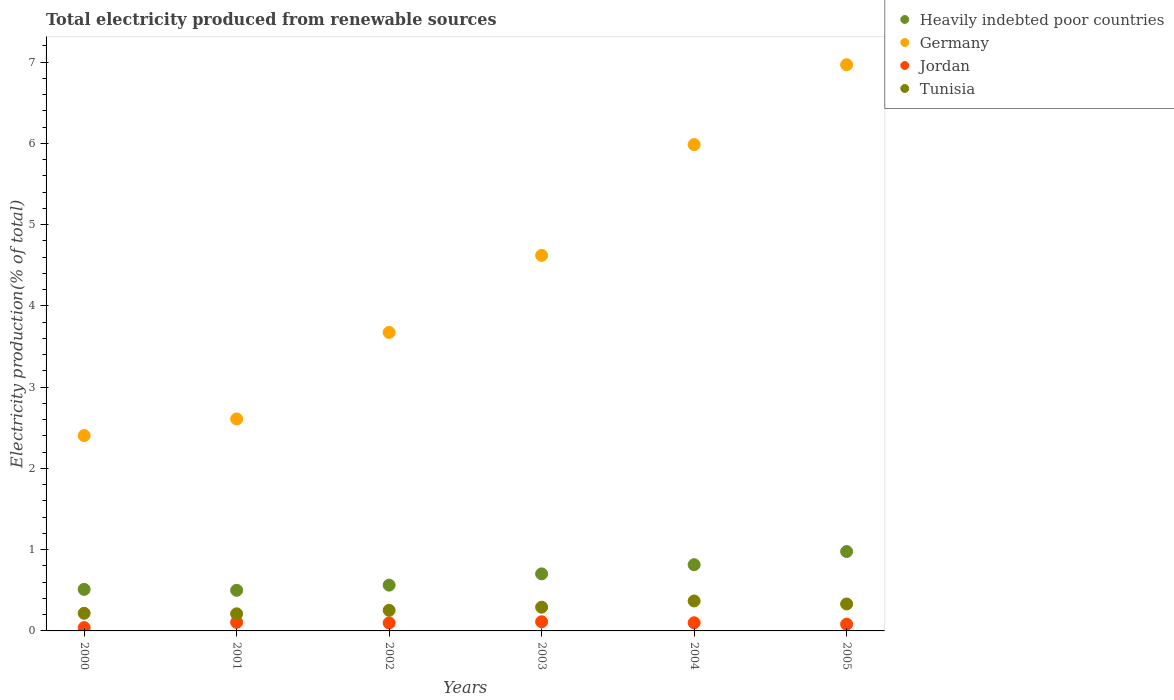How many different coloured dotlines are there?
Your answer should be compact. 4. What is the total electricity produced in Tunisia in 2001?
Offer a very short reply. 0.21. Across all years, what is the maximum total electricity produced in Jordan?
Offer a very short reply. 0.11. Across all years, what is the minimum total electricity produced in Germany?
Your response must be concise. 2.4. In which year was the total electricity produced in Jordan maximum?
Your answer should be very brief. 2003. In which year was the total electricity produced in Heavily indebted poor countries minimum?
Keep it short and to the point. 2001. What is the total total electricity produced in Jordan in the graph?
Provide a succinct answer. 0.54. What is the difference between the total electricity produced in Jordan in 2001 and that in 2002?
Keep it short and to the point. 0.01. What is the difference between the total electricity produced in Jordan in 2003 and the total electricity produced in Heavily indebted poor countries in 2000?
Your response must be concise. -0.4. What is the average total electricity produced in Germany per year?
Keep it short and to the point. 4.38. In the year 2000, what is the difference between the total electricity produced in Jordan and total electricity produced in Heavily indebted poor countries?
Your answer should be compact. -0.47. What is the ratio of the total electricity produced in Jordan in 2000 to that in 2004?
Make the answer very short. 0.41. Is the total electricity produced in Germany in 2002 less than that in 2005?
Ensure brevity in your answer.  Yes. What is the difference between the highest and the second highest total electricity produced in Jordan?
Keep it short and to the point. 0.01. What is the difference between the highest and the lowest total electricity produced in Germany?
Provide a succinct answer. 4.56. In how many years, is the total electricity produced in Jordan greater than the average total electricity produced in Jordan taken over all years?
Provide a succinct answer. 4. Is the sum of the total electricity produced in Tunisia in 2001 and 2002 greater than the maximum total electricity produced in Jordan across all years?
Offer a very short reply. Yes. Does the total electricity produced in Tunisia monotonically increase over the years?
Ensure brevity in your answer.  No. Is the total electricity produced in Heavily indebted poor countries strictly less than the total electricity produced in Germany over the years?
Make the answer very short. Yes. How many years are there in the graph?
Give a very brief answer. 6. What is the difference between two consecutive major ticks on the Y-axis?
Your answer should be compact. 1. Are the values on the major ticks of Y-axis written in scientific E-notation?
Ensure brevity in your answer.  No. Does the graph contain any zero values?
Your response must be concise. No. Does the graph contain grids?
Your response must be concise. No. Where does the legend appear in the graph?
Give a very brief answer. Top right. How many legend labels are there?
Make the answer very short. 4. How are the legend labels stacked?
Provide a succinct answer. Vertical. What is the title of the graph?
Your answer should be very brief. Total electricity produced from renewable sources. Does "Least developed countries" appear as one of the legend labels in the graph?
Ensure brevity in your answer.  No. What is the label or title of the Y-axis?
Keep it short and to the point. Electricity production(% of total). What is the Electricity production(% of total) in Heavily indebted poor countries in 2000?
Give a very brief answer. 0.51. What is the Electricity production(% of total) in Germany in 2000?
Offer a terse response. 2.4. What is the Electricity production(% of total) in Jordan in 2000?
Ensure brevity in your answer.  0.04. What is the Electricity production(% of total) in Tunisia in 2000?
Your answer should be very brief. 0.22. What is the Electricity production(% of total) in Heavily indebted poor countries in 2001?
Make the answer very short. 0.5. What is the Electricity production(% of total) in Germany in 2001?
Give a very brief answer. 2.61. What is the Electricity production(% of total) of Jordan in 2001?
Give a very brief answer. 0.11. What is the Electricity production(% of total) of Tunisia in 2001?
Ensure brevity in your answer.  0.21. What is the Electricity production(% of total) in Heavily indebted poor countries in 2002?
Your answer should be very brief. 0.56. What is the Electricity production(% of total) of Germany in 2002?
Make the answer very short. 3.67. What is the Electricity production(% of total) of Jordan in 2002?
Make the answer very short. 0.1. What is the Electricity production(% of total) of Tunisia in 2002?
Keep it short and to the point. 0.25. What is the Electricity production(% of total) in Heavily indebted poor countries in 2003?
Keep it short and to the point. 0.7. What is the Electricity production(% of total) in Germany in 2003?
Your answer should be compact. 4.62. What is the Electricity production(% of total) of Jordan in 2003?
Keep it short and to the point. 0.11. What is the Electricity production(% of total) in Tunisia in 2003?
Your answer should be compact. 0.29. What is the Electricity production(% of total) in Heavily indebted poor countries in 2004?
Ensure brevity in your answer.  0.82. What is the Electricity production(% of total) in Germany in 2004?
Provide a succinct answer. 5.99. What is the Electricity production(% of total) in Jordan in 2004?
Provide a succinct answer. 0.1. What is the Electricity production(% of total) in Tunisia in 2004?
Your answer should be compact. 0.37. What is the Electricity production(% of total) of Heavily indebted poor countries in 2005?
Ensure brevity in your answer.  0.98. What is the Electricity production(% of total) in Germany in 2005?
Your answer should be very brief. 6.97. What is the Electricity production(% of total) in Jordan in 2005?
Your answer should be compact. 0.08. What is the Electricity production(% of total) in Tunisia in 2005?
Offer a very short reply. 0.33. Across all years, what is the maximum Electricity production(% of total) of Heavily indebted poor countries?
Your answer should be compact. 0.98. Across all years, what is the maximum Electricity production(% of total) of Germany?
Offer a very short reply. 6.97. Across all years, what is the maximum Electricity production(% of total) in Jordan?
Your answer should be compact. 0.11. Across all years, what is the maximum Electricity production(% of total) of Tunisia?
Make the answer very short. 0.37. Across all years, what is the minimum Electricity production(% of total) in Heavily indebted poor countries?
Keep it short and to the point. 0.5. Across all years, what is the minimum Electricity production(% of total) of Germany?
Your answer should be very brief. 2.4. Across all years, what is the minimum Electricity production(% of total) of Jordan?
Ensure brevity in your answer.  0.04. Across all years, what is the minimum Electricity production(% of total) of Tunisia?
Provide a short and direct response. 0.21. What is the total Electricity production(% of total) of Heavily indebted poor countries in the graph?
Provide a short and direct response. 4.07. What is the total Electricity production(% of total) of Germany in the graph?
Keep it short and to the point. 26.26. What is the total Electricity production(% of total) of Jordan in the graph?
Your response must be concise. 0.54. What is the total Electricity production(% of total) in Tunisia in the graph?
Your response must be concise. 1.67. What is the difference between the Electricity production(% of total) of Heavily indebted poor countries in 2000 and that in 2001?
Give a very brief answer. 0.01. What is the difference between the Electricity production(% of total) in Germany in 2000 and that in 2001?
Ensure brevity in your answer.  -0.2. What is the difference between the Electricity production(% of total) in Jordan in 2000 and that in 2001?
Offer a terse response. -0.07. What is the difference between the Electricity production(% of total) of Tunisia in 2000 and that in 2001?
Provide a succinct answer. 0.01. What is the difference between the Electricity production(% of total) in Heavily indebted poor countries in 2000 and that in 2002?
Your answer should be compact. -0.05. What is the difference between the Electricity production(% of total) of Germany in 2000 and that in 2002?
Provide a short and direct response. -1.27. What is the difference between the Electricity production(% of total) of Jordan in 2000 and that in 2002?
Provide a short and direct response. -0.06. What is the difference between the Electricity production(% of total) of Tunisia in 2000 and that in 2002?
Give a very brief answer. -0.04. What is the difference between the Electricity production(% of total) of Heavily indebted poor countries in 2000 and that in 2003?
Offer a terse response. -0.19. What is the difference between the Electricity production(% of total) in Germany in 2000 and that in 2003?
Offer a terse response. -2.22. What is the difference between the Electricity production(% of total) in Jordan in 2000 and that in 2003?
Keep it short and to the point. -0.07. What is the difference between the Electricity production(% of total) in Tunisia in 2000 and that in 2003?
Provide a succinct answer. -0.08. What is the difference between the Electricity production(% of total) of Heavily indebted poor countries in 2000 and that in 2004?
Provide a short and direct response. -0.3. What is the difference between the Electricity production(% of total) in Germany in 2000 and that in 2004?
Provide a short and direct response. -3.58. What is the difference between the Electricity production(% of total) of Jordan in 2000 and that in 2004?
Your answer should be very brief. -0.06. What is the difference between the Electricity production(% of total) of Tunisia in 2000 and that in 2004?
Your answer should be very brief. -0.15. What is the difference between the Electricity production(% of total) in Heavily indebted poor countries in 2000 and that in 2005?
Offer a terse response. -0.47. What is the difference between the Electricity production(% of total) of Germany in 2000 and that in 2005?
Offer a terse response. -4.56. What is the difference between the Electricity production(% of total) in Jordan in 2000 and that in 2005?
Your response must be concise. -0.04. What is the difference between the Electricity production(% of total) in Tunisia in 2000 and that in 2005?
Give a very brief answer. -0.11. What is the difference between the Electricity production(% of total) of Heavily indebted poor countries in 2001 and that in 2002?
Provide a short and direct response. -0.06. What is the difference between the Electricity production(% of total) of Germany in 2001 and that in 2002?
Give a very brief answer. -1.06. What is the difference between the Electricity production(% of total) in Jordan in 2001 and that in 2002?
Your answer should be compact. 0.01. What is the difference between the Electricity production(% of total) in Tunisia in 2001 and that in 2002?
Make the answer very short. -0.04. What is the difference between the Electricity production(% of total) in Heavily indebted poor countries in 2001 and that in 2003?
Make the answer very short. -0.2. What is the difference between the Electricity production(% of total) of Germany in 2001 and that in 2003?
Offer a terse response. -2.01. What is the difference between the Electricity production(% of total) in Jordan in 2001 and that in 2003?
Make the answer very short. -0.01. What is the difference between the Electricity production(% of total) in Tunisia in 2001 and that in 2003?
Ensure brevity in your answer.  -0.08. What is the difference between the Electricity production(% of total) in Heavily indebted poor countries in 2001 and that in 2004?
Make the answer very short. -0.32. What is the difference between the Electricity production(% of total) of Germany in 2001 and that in 2004?
Ensure brevity in your answer.  -3.38. What is the difference between the Electricity production(% of total) in Jordan in 2001 and that in 2004?
Provide a short and direct response. 0.01. What is the difference between the Electricity production(% of total) in Tunisia in 2001 and that in 2004?
Your answer should be very brief. -0.16. What is the difference between the Electricity production(% of total) of Heavily indebted poor countries in 2001 and that in 2005?
Keep it short and to the point. -0.48. What is the difference between the Electricity production(% of total) of Germany in 2001 and that in 2005?
Provide a short and direct response. -4.36. What is the difference between the Electricity production(% of total) in Jordan in 2001 and that in 2005?
Make the answer very short. 0.02. What is the difference between the Electricity production(% of total) in Tunisia in 2001 and that in 2005?
Provide a succinct answer. -0.12. What is the difference between the Electricity production(% of total) of Heavily indebted poor countries in 2002 and that in 2003?
Provide a short and direct response. -0.14. What is the difference between the Electricity production(% of total) in Germany in 2002 and that in 2003?
Provide a short and direct response. -0.95. What is the difference between the Electricity production(% of total) in Jordan in 2002 and that in 2003?
Make the answer very short. -0.01. What is the difference between the Electricity production(% of total) in Tunisia in 2002 and that in 2003?
Offer a very short reply. -0.04. What is the difference between the Electricity production(% of total) in Heavily indebted poor countries in 2002 and that in 2004?
Your response must be concise. -0.25. What is the difference between the Electricity production(% of total) of Germany in 2002 and that in 2004?
Offer a very short reply. -2.31. What is the difference between the Electricity production(% of total) of Jordan in 2002 and that in 2004?
Make the answer very short. -0. What is the difference between the Electricity production(% of total) of Tunisia in 2002 and that in 2004?
Offer a very short reply. -0.12. What is the difference between the Electricity production(% of total) of Heavily indebted poor countries in 2002 and that in 2005?
Keep it short and to the point. -0.41. What is the difference between the Electricity production(% of total) in Germany in 2002 and that in 2005?
Ensure brevity in your answer.  -3.29. What is the difference between the Electricity production(% of total) in Jordan in 2002 and that in 2005?
Your response must be concise. 0.02. What is the difference between the Electricity production(% of total) in Tunisia in 2002 and that in 2005?
Offer a very short reply. -0.08. What is the difference between the Electricity production(% of total) in Heavily indebted poor countries in 2003 and that in 2004?
Offer a terse response. -0.11. What is the difference between the Electricity production(% of total) in Germany in 2003 and that in 2004?
Offer a terse response. -1.36. What is the difference between the Electricity production(% of total) of Jordan in 2003 and that in 2004?
Keep it short and to the point. 0.01. What is the difference between the Electricity production(% of total) of Tunisia in 2003 and that in 2004?
Offer a very short reply. -0.08. What is the difference between the Electricity production(% of total) in Heavily indebted poor countries in 2003 and that in 2005?
Provide a short and direct response. -0.28. What is the difference between the Electricity production(% of total) of Germany in 2003 and that in 2005?
Your response must be concise. -2.35. What is the difference between the Electricity production(% of total) in Jordan in 2003 and that in 2005?
Ensure brevity in your answer.  0.03. What is the difference between the Electricity production(% of total) in Tunisia in 2003 and that in 2005?
Offer a very short reply. -0.04. What is the difference between the Electricity production(% of total) in Heavily indebted poor countries in 2004 and that in 2005?
Keep it short and to the point. -0.16. What is the difference between the Electricity production(% of total) of Germany in 2004 and that in 2005?
Provide a succinct answer. -0.98. What is the difference between the Electricity production(% of total) of Jordan in 2004 and that in 2005?
Provide a short and direct response. 0.02. What is the difference between the Electricity production(% of total) of Tunisia in 2004 and that in 2005?
Keep it short and to the point. 0.04. What is the difference between the Electricity production(% of total) of Heavily indebted poor countries in 2000 and the Electricity production(% of total) of Germany in 2001?
Offer a terse response. -2.1. What is the difference between the Electricity production(% of total) in Heavily indebted poor countries in 2000 and the Electricity production(% of total) in Jordan in 2001?
Provide a succinct answer. 0.41. What is the difference between the Electricity production(% of total) of Heavily indebted poor countries in 2000 and the Electricity production(% of total) of Tunisia in 2001?
Keep it short and to the point. 0.3. What is the difference between the Electricity production(% of total) of Germany in 2000 and the Electricity production(% of total) of Jordan in 2001?
Your answer should be very brief. 2.3. What is the difference between the Electricity production(% of total) in Germany in 2000 and the Electricity production(% of total) in Tunisia in 2001?
Ensure brevity in your answer.  2.19. What is the difference between the Electricity production(% of total) in Jordan in 2000 and the Electricity production(% of total) in Tunisia in 2001?
Provide a short and direct response. -0.17. What is the difference between the Electricity production(% of total) in Heavily indebted poor countries in 2000 and the Electricity production(% of total) in Germany in 2002?
Offer a very short reply. -3.16. What is the difference between the Electricity production(% of total) in Heavily indebted poor countries in 2000 and the Electricity production(% of total) in Jordan in 2002?
Provide a succinct answer. 0.41. What is the difference between the Electricity production(% of total) of Heavily indebted poor countries in 2000 and the Electricity production(% of total) of Tunisia in 2002?
Provide a short and direct response. 0.26. What is the difference between the Electricity production(% of total) in Germany in 2000 and the Electricity production(% of total) in Jordan in 2002?
Your response must be concise. 2.31. What is the difference between the Electricity production(% of total) of Germany in 2000 and the Electricity production(% of total) of Tunisia in 2002?
Provide a succinct answer. 2.15. What is the difference between the Electricity production(% of total) of Jordan in 2000 and the Electricity production(% of total) of Tunisia in 2002?
Your answer should be compact. -0.21. What is the difference between the Electricity production(% of total) in Heavily indebted poor countries in 2000 and the Electricity production(% of total) in Germany in 2003?
Your answer should be compact. -4.11. What is the difference between the Electricity production(% of total) of Heavily indebted poor countries in 2000 and the Electricity production(% of total) of Jordan in 2003?
Your response must be concise. 0.4. What is the difference between the Electricity production(% of total) of Heavily indebted poor countries in 2000 and the Electricity production(% of total) of Tunisia in 2003?
Your response must be concise. 0.22. What is the difference between the Electricity production(% of total) of Germany in 2000 and the Electricity production(% of total) of Jordan in 2003?
Provide a succinct answer. 2.29. What is the difference between the Electricity production(% of total) in Germany in 2000 and the Electricity production(% of total) in Tunisia in 2003?
Offer a terse response. 2.11. What is the difference between the Electricity production(% of total) in Jordan in 2000 and the Electricity production(% of total) in Tunisia in 2003?
Offer a terse response. -0.25. What is the difference between the Electricity production(% of total) of Heavily indebted poor countries in 2000 and the Electricity production(% of total) of Germany in 2004?
Your answer should be compact. -5.47. What is the difference between the Electricity production(% of total) in Heavily indebted poor countries in 2000 and the Electricity production(% of total) in Jordan in 2004?
Keep it short and to the point. 0.41. What is the difference between the Electricity production(% of total) of Heavily indebted poor countries in 2000 and the Electricity production(% of total) of Tunisia in 2004?
Provide a succinct answer. 0.14. What is the difference between the Electricity production(% of total) of Germany in 2000 and the Electricity production(% of total) of Jordan in 2004?
Your response must be concise. 2.3. What is the difference between the Electricity production(% of total) of Germany in 2000 and the Electricity production(% of total) of Tunisia in 2004?
Give a very brief answer. 2.04. What is the difference between the Electricity production(% of total) in Jordan in 2000 and the Electricity production(% of total) in Tunisia in 2004?
Provide a short and direct response. -0.33. What is the difference between the Electricity production(% of total) in Heavily indebted poor countries in 2000 and the Electricity production(% of total) in Germany in 2005?
Your answer should be very brief. -6.46. What is the difference between the Electricity production(% of total) in Heavily indebted poor countries in 2000 and the Electricity production(% of total) in Jordan in 2005?
Offer a very short reply. 0.43. What is the difference between the Electricity production(% of total) of Heavily indebted poor countries in 2000 and the Electricity production(% of total) of Tunisia in 2005?
Your answer should be compact. 0.18. What is the difference between the Electricity production(% of total) in Germany in 2000 and the Electricity production(% of total) in Jordan in 2005?
Make the answer very short. 2.32. What is the difference between the Electricity production(% of total) in Germany in 2000 and the Electricity production(% of total) in Tunisia in 2005?
Make the answer very short. 2.07. What is the difference between the Electricity production(% of total) of Jordan in 2000 and the Electricity production(% of total) of Tunisia in 2005?
Ensure brevity in your answer.  -0.29. What is the difference between the Electricity production(% of total) in Heavily indebted poor countries in 2001 and the Electricity production(% of total) in Germany in 2002?
Your answer should be compact. -3.17. What is the difference between the Electricity production(% of total) in Heavily indebted poor countries in 2001 and the Electricity production(% of total) in Jordan in 2002?
Give a very brief answer. 0.4. What is the difference between the Electricity production(% of total) in Heavily indebted poor countries in 2001 and the Electricity production(% of total) in Tunisia in 2002?
Keep it short and to the point. 0.25. What is the difference between the Electricity production(% of total) in Germany in 2001 and the Electricity production(% of total) in Jordan in 2002?
Your answer should be very brief. 2.51. What is the difference between the Electricity production(% of total) in Germany in 2001 and the Electricity production(% of total) in Tunisia in 2002?
Provide a succinct answer. 2.36. What is the difference between the Electricity production(% of total) of Jordan in 2001 and the Electricity production(% of total) of Tunisia in 2002?
Give a very brief answer. -0.15. What is the difference between the Electricity production(% of total) of Heavily indebted poor countries in 2001 and the Electricity production(% of total) of Germany in 2003?
Offer a terse response. -4.12. What is the difference between the Electricity production(% of total) of Heavily indebted poor countries in 2001 and the Electricity production(% of total) of Jordan in 2003?
Keep it short and to the point. 0.39. What is the difference between the Electricity production(% of total) of Heavily indebted poor countries in 2001 and the Electricity production(% of total) of Tunisia in 2003?
Provide a succinct answer. 0.21. What is the difference between the Electricity production(% of total) of Germany in 2001 and the Electricity production(% of total) of Jordan in 2003?
Your answer should be compact. 2.5. What is the difference between the Electricity production(% of total) in Germany in 2001 and the Electricity production(% of total) in Tunisia in 2003?
Offer a terse response. 2.32. What is the difference between the Electricity production(% of total) in Jordan in 2001 and the Electricity production(% of total) in Tunisia in 2003?
Your response must be concise. -0.19. What is the difference between the Electricity production(% of total) in Heavily indebted poor countries in 2001 and the Electricity production(% of total) in Germany in 2004?
Offer a terse response. -5.49. What is the difference between the Electricity production(% of total) of Heavily indebted poor countries in 2001 and the Electricity production(% of total) of Jordan in 2004?
Offer a very short reply. 0.4. What is the difference between the Electricity production(% of total) of Heavily indebted poor countries in 2001 and the Electricity production(% of total) of Tunisia in 2004?
Your response must be concise. 0.13. What is the difference between the Electricity production(% of total) in Germany in 2001 and the Electricity production(% of total) in Jordan in 2004?
Offer a terse response. 2.51. What is the difference between the Electricity production(% of total) of Germany in 2001 and the Electricity production(% of total) of Tunisia in 2004?
Your answer should be very brief. 2.24. What is the difference between the Electricity production(% of total) of Jordan in 2001 and the Electricity production(% of total) of Tunisia in 2004?
Ensure brevity in your answer.  -0.26. What is the difference between the Electricity production(% of total) of Heavily indebted poor countries in 2001 and the Electricity production(% of total) of Germany in 2005?
Your answer should be very brief. -6.47. What is the difference between the Electricity production(% of total) in Heavily indebted poor countries in 2001 and the Electricity production(% of total) in Jordan in 2005?
Your answer should be compact. 0.42. What is the difference between the Electricity production(% of total) in Heavily indebted poor countries in 2001 and the Electricity production(% of total) in Tunisia in 2005?
Your response must be concise. 0.17. What is the difference between the Electricity production(% of total) in Germany in 2001 and the Electricity production(% of total) in Jordan in 2005?
Offer a terse response. 2.53. What is the difference between the Electricity production(% of total) in Germany in 2001 and the Electricity production(% of total) in Tunisia in 2005?
Provide a short and direct response. 2.28. What is the difference between the Electricity production(% of total) in Jordan in 2001 and the Electricity production(% of total) in Tunisia in 2005?
Ensure brevity in your answer.  -0.23. What is the difference between the Electricity production(% of total) of Heavily indebted poor countries in 2002 and the Electricity production(% of total) of Germany in 2003?
Ensure brevity in your answer.  -4.06. What is the difference between the Electricity production(% of total) of Heavily indebted poor countries in 2002 and the Electricity production(% of total) of Jordan in 2003?
Provide a succinct answer. 0.45. What is the difference between the Electricity production(% of total) in Heavily indebted poor countries in 2002 and the Electricity production(% of total) in Tunisia in 2003?
Offer a terse response. 0.27. What is the difference between the Electricity production(% of total) of Germany in 2002 and the Electricity production(% of total) of Jordan in 2003?
Keep it short and to the point. 3.56. What is the difference between the Electricity production(% of total) in Germany in 2002 and the Electricity production(% of total) in Tunisia in 2003?
Your answer should be compact. 3.38. What is the difference between the Electricity production(% of total) in Jordan in 2002 and the Electricity production(% of total) in Tunisia in 2003?
Make the answer very short. -0.19. What is the difference between the Electricity production(% of total) of Heavily indebted poor countries in 2002 and the Electricity production(% of total) of Germany in 2004?
Your answer should be very brief. -5.42. What is the difference between the Electricity production(% of total) in Heavily indebted poor countries in 2002 and the Electricity production(% of total) in Jordan in 2004?
Offer a terse response. 0.46. What is the difference between the Electricity production(% of total) of Heavily indebted poor countries in 2002 and the Electricity production(% of total) of Tunisia in 2004?
Make the answer very short. 0.2. What is the difference between the Electricity production(% of total) of Germany in 2002 and the Electricity production(% of total) of Jordan in 2004?
Your response must be concise. 3.57. What is the difference between the Electricity production(% of total) of Germany in 2002 and the Electricity production(% of total) of Tunisia in 2004?
Provide a short and direct response. 3.31. What is the difference between the Electricity production(% of total) of Jordan in 2002 and the Electricity production(% of total) of Tunisia in 2004?
Offer a very short reply. -0.27. What is the difference between the Electricity production(% of total) in Heavily indebted poor countries in 2002 and the Electricity production(% of total) in Germany in 2005?
Ensure brevity in your answer.  -6.41. What is the difference between the Electricity production(% of total) in Heavily indebted poor countries in 2002 and the Electricity production(% of total) in Jordan in 2005?
Provide a succinct answer. 0.48. What is the difference between the Electricity production(% of total) in Heavily indebted poor countries in 2002 and the Electricity production(% of total) in Tunisia in 2005?
Ensure brevity in your answer.  0.23. What is the difference between the Electricity production(% of total) in Germany in 2002 and the Electricity production(% of total) in Jordan in 2005?
Your answer should be very brief. 3.59. What is the difference between the Electricity production(% of total) of Germany in 2002 and the Electricity production(% of total) of Tunisia in 2005?
Offer a very short reply. 3.34. What is the difference between the Electricity production(% of total) in Jordan in 2002 and the Electricity production(% of total) in Tunisia in 2005?
Make the answer very short. -0.23. What is the difference between the Electricity production(% of total) of Heavily indebted poor countries in 2003 and the Electricity production(% of total) of Germany in 2004?
Your answer should be compact. -5.28. What is the difference between the Electricity production(% of total) of Heavily indebted poor countries in 2003 and the Electricity production(% of total) of Jordan in 2004?
Offer a very short reply. 0.6. What is the difference between the Electricity production(% of total) in Heavily indebted poor countries in 2003 and the Electricity production(% of total) in Tunisia in 2004?
Your answer should be compact. 0.33. What is the difference between the Electricity production(% of total) in Germany in 2003 and the Electricity production(% of total) in Jordan in 2004?
Your answer should be compact. 4.52. What is the difference between the Electricity production(% of total) of Germany in 2003 and the Electricity production(% of total) of Tunisia in 2004?
Give a very brief answer. 4.25. What is the difference between the Electricity production(% of total) in Jordan in 2003 and the Electricity production(% of total) in Tunisia in 2004?
Offer a very short reply. -0.26. What is the difference between the Electricity production(% of total) of Heavily indebted poor countries in 2003 and the Electricity production(% of total) of Germany in 2005?
Provide a short and direct response. -6.27. What is the difference between the Electricity production(% of total) of Heavily indebted poor countries in 2003 and the Electricity production(% of total) of Jordan in 2005?
Give a very brief answer. 0.62. What is the difference between the Electricity production(% of total) in Heavily indebted poor countries in 2003 and the Electricity production(% of total) in Tunisia in 2005?
Offer a terse response. 0.37. What is the difference between the Electricity production(% of total) of Germany in 2003 and the Electricity production(% of total) of Jordan in 2005?
Your response must be concise. 4.54. What is the difference between the Electricity production(% of total) in Germany in 2003 and the Electricity production(% of total) in Tunisia in 2005?
Your response must be concise. 4.29. What is the difference between the Electricity production(% of total) of Jordan in 2003 and the Electricity production(% of total) of Tunisia in 2005?
Offer a very short reply. -0.22. What is the difference between the Electricity production(% of total) of Heavily indebted poor countries in 2004 and the Electricity production(% of total) of Germany in 2005?
Keep it short and to the point. -6.15. What is the difference between the Electricity production(% of total) of Heavily indebted poor countries in 2004 and the Electricity production(% of total) of Jordan in 2005?
Make the answer very short. 0.73. What is the difference between the Electricity production(% of total) of Heavily indebted poor countries in 2004 and the Electricity production(% of total) of Tunisia in 2005?
Your response must be concise. 0.48. What is the difference between the Electricity production(% of total) in Germany in 2004 and the Electricity production(% of total) in Jordan in 2005?
Your response must be concise. 5.9. What is the difference between the Electricity production(% of total) in Germany in 2004 and the Electricity production(% of total) in Tunisia in 2005?
Provide a short and direct response. 5.65. What is the difference between the Electricity production(% of total) of Jordan in 2004 and the Electricity production(% of total) of Tunisia in 2005?
Offer a very short reply. -0.23. What is the average Electricity production(% of total) of Heavily indebted poor countries per year?
Your answer should be compact. 0.68. What is the average Electricity production(% of total) in Germany per year?
Your answer should be compact. 4.38. What is the average Electricity production(% of total) in Jordan per year?
Provide a succinct answer. 0.09. What is the average Electricity production(% of total) in Tunisia per year?
Offer a very short reply. 0.28. In the year 2000, what is the difference between the Electricity production(% of total) in Heavily indebted poor countries and Electricity production(% of total) in Germany?
Your response must be concise. -1.89. In the year 2000, what is the difference between the Electricity production(% of total) of Heavily indebted poor countries and Electricity production(% of total) of Jordan?
Ensure brevity in your answer.  0.47. In the year 2000, what is the difference between the Electricity production(% of total) of Heavily indebted poor countries and Electricity production(% of total) of Tunisia?
Make the answer very short. 0.29. In the year 2000, what is the difference between the Electricity production(% of total) in Germany and Electricity production(% of total) in Jordan?
Give a very brief answer. 2.36. In the year 2000, what is the difference between the Electricity production(% of total) of Germany and Electricity production(% of total) of Tunisia?
Your answer should be compact. 2.19. In the year 2000, what is the difference between the Electricity production(% of total) of Jordan and Electricity production(% of total) of Tunisia?
Give a very brief answer. -0.18. In the year 2001, what is the difference between the Electricity production(% of total) in Heavily indebted poor countries and Electricity production(% of total) in Germany?
Keep it short and to the point. -2.11. In the year 2001, what is the difference between the Electricity production(% of total) in Heavily indebted poor countries and Electricity production(% of total) in Jordan?
Offer a very short reply. 0.39. In the year 2001, what is the difference between the Electricity production(% of total) in Heavily indebted poor countries and Electricity production(% of total) in Tunisia?
Ensure brevity in your answer.  0.29. In the year 2001, what is the difference between the Electricity production(% of total) in Germany and Electricity production(% of total) in Jordan?
Offer a very short reply. 2.5. In the year 2001, what is the difference between the Electricity production(% of total) in Germany and Electricity production(% of total) in Tunisia?
Your response must be concise. 2.4. In the year 2001, what is the difference between the Electricity production(% of total) in Jordan and Electricity production(% of total) in Tunisia?
Keep it short and to the point. -0.1. In the year 2002, what is the difference between the Electricity production(% of total) in Heavily indebted poor countries and Electricity production(% of total) in Germany?
Your response must be concise. -3.11. In the year 2002, what is the difference between the Electricity production(% of total) in Heavily indebted poor countries and Electricity production(% of total) in Jordan?
Offer a very short reply. 0.47. In the year 2002, what is the difference between the Electricity production(% of total) in Heavily indebted poor countries and Electricity production(% of total) in Tunisia?
Provide a succinct answer. 0.31. In the year 2002, what is the difference between the Electricity production(% of total) of Germany and Electricity production(% of total) of Jordan?
Your answer should be very brief. 3.58. In the year 2002, what is the difference between the Electricity production(% of total) in Germany and Electricity production(% of total) in Tunisia?
Keep it short and to the point. 3.42. In the year 2002, what is the difference between the Electricity production(% of total) of Jordan and Electricity production(% of total) of Tunisia?
Ensure brevity in your answer.  -0.15. In the year 2003, what is the difference between the Electricity production(% of total) of Heavily indebted poor countries and Electricity production(% of total) of Germany?
Give a very brief answer. -3.92. In the year 2003, what is the difference between the Electricity production(% of total) of Heavily indebted poor countries and Electricity production(% of total) of Jordan?
Keep it short and to the point. 0.59. In the year 2003, what is the difference between the Electricity production(% of total) in Heavily indebted poor countries and Electricity production(% of total) in Tunisia?
Provide a short and direct response. 0.41. In the year 2003, what is the difference between the Electricity production(% of total) of Germany and Electricity production(% of total) of Jordan?
Keep it short and to the point. 4.51. In the year 2003, what is the difference between the Electricity production(% of total) in Germany and Electricity production(% of total) in Tunisia?
Provide a succinct answer. 4.33. In the year 2003, what is the difference between the Electricity production(% of total) in Jordan and Electricity production(% of total) in Tunisia?
Your answer should be very brief. -0.18. In the year 2004, what is the difference between the Electricity production(% of total) in Heavily indebted poor countries and Electricity production(% of total) in Germany?
Your answer should be very brief. -5.17. In the year 2004, what is the difference between the Electricity production(% of total) of Heavily indebted poor countries and Electricity production(% of total) of Jordan?
Your answer should be very brief. 0.71. In the year 2004, what is the difference between the Electricity production(% of total) of Heavily indebted poor countries and Electricity production(% of total) of Tunisia?
Give a very brief answer. 0.45. In the year 2004, what is the difference between the Electricity production(% of total) in Germany and Electricity production(% of total) in Jordan?
Provide a succinct answer. 5.88. In the year 2004, what is the difference between the Electricity production(% of total) of Germany and Electricity production(% of total) of Tunisia?
Provide a succinct answer. 5.62. In the year 2004, what is the difference between the Electricity production(% of total) of Jordan and Electricity production(% of total) of Tunisia?
Provide a succinct answer. -0.27. In the year 2005, what is the difference between the Electricity production(% of total) in Heavily indebted poor countries and Electricity production(% of total) in Germany?
Make the answer very short. -5.99. In the year 2005, what is the difference between the Electricity production(% of total) in Heavily indebted poor countries and Electricity production(% of total) in Jordan?
Provide a succinct answer. 0.89. In the year 2005, what is the difference between the Electricity production(% of total) of Heavily indebted poor countries and Electricity production(% of total) of Tunisia?
Your answer should be very brief. 0.65. In the year 2005, what is the difference between the Electricity production(% of total) of Germany and Electricity production(% of total) of Jordan?
Ensure brevity in your answer.  6.89. In the year 2005, what is the difference between the Electricity production(% of total) in Germany and Electricity production(% of total) in Tunisia?
Keep it short and to the point. 6.64. In the year 2005, what is the difference between the Electricity production(% of total) in Jordan and Electricity production(% of total) in Tunisia?
Make the answer very short. -0.25. What is the ratio of the Electricity production(% of total) of Heavily indebted poor countries in 2000 to that in 2001?
Offer a terse response. 1.02. What is the ratio of the Electricity production(% of total) of Germany in 2000 to that in 2001?
Offer a very short reply. 0.92. What is the ratio of the Electricity production(% of total) in Jordan in 2000 to that in 2001?
Your response must be concise. 0.38. What is the ratio of the Electricity production(% of total) of Tunisia in 2000 to that in 2001?
Provide a short and direct response. 1.03. What is the ratio of the Electricity production(% of total) in Heavily indebted poor countries in 2000 to that in 2002?
Your answer should be compact. 0.91. What is the ratio of the Electricity production(% of total) of Germany in 2000 to that in 2002?
Offer a terse response. 0.65. What is the ratio of the Electricity production(% of total) of Jordan in 2000 to that in 2002?
Offer a very short reply. 0.41. What is the ratio of the Electricity production(% of total) of Tunisia in 2000 to that in 2002?
Make the answer very short. 0.86. What is the ratio of the Electricity production(% of total) in Heavily indebted poor countries in 2000 to that in 2003?
Give a very brief answer. 0.73. What is the ratio of the Electricity production(% of total) of Germany in 2000 to that in 2003?
Offer a terse response. 0.52. What is the ratio of the Electricity production(% of total) of Jordan in 2000 to that in 2003?
Your answer should be very brief. 0.36. What is the ratio of the Electricity production(% of total) in Tunisia in 2000 to that in 2003?
Offer a terse response. 0.74. What is the ratio of the Electricity production(% of total) in Heavily indebted poor countries in 2000 to that in 2004?
Provide a succinct answer. 0.63. What is the ratio of the Electricity production(% of total) of Germany in 2000 to that in 2004?
Offer a terse response. 0.4. What is the ratio of the Electricity production(% of total) of Jordan in 2000 to that in 2004?
Your answer should be very brief. 0.41. What is the ratio of the Electricity production(% of total) of Tunisia in 2000 to that in 2004?
Make the answer very short. 0.59. What is the ratio of the Electricity production(% of total) of Heavily indebted poor countries in 2000 to that in 2005?
Give a very brief answer. 0.52. What is the ratio of the Electricity production(% of total) of Germany in 2000 to that in 2005?
Keep it short and to the point. 0.34. What is the ratio of the Electricity production(% of total) of Jordan in 2000 to that in 2005?
Offer a terse response. 0.49. What is the ratio of the Electricity production(% of total) of Tunisia in 2000 to that in 2005?
Ensure brevity in your answer.  0.65. What is the ratio of the Electricity production(% of total) of Heavily indebted poor countries in 2001 to that in 2002?
Your response must be concise. 0.89. What is the ratio of the Electricity production(% of total) of Germany in 2001 to that in 2002?
Make the answer very short. 0.71. What is the ratio of the Electricity production(% of total) of Jordan in 2001 to that in 2002?
Ensure brevity in your answer.  1.08. What is the ratio of the Electricity production(% of total) in Tunisia in 2001 to that in 2002?
Your response must be concise. 0.83. What is the ratio of the Electricity production(% of total) of Heavily indebted poor countries in 2001 to that in 2003?
Offer a very short reply. 0.71. What is the ratio of the Electricity production(% of total) of Germany in 2001 to that in 2003?
Offer a very short reply. 0.56. What is the ratio of the Electricity production(% of total) in Jordan in 2001 to that in 2003?
Keep it short and to the point. 0.94. What is the ratio of the Electricity production(% of total) in Tunisia in 2001 to that in 2003?
Offer a very short reply. 0.72. What is the ratio of the Electricity production(% of total) in Heavily indebted poor countries in 2001 to that in 2004?
Provide a short and direct response. 0.61. What is the ratio of the Electricity production(% of total) of Germany in 2001 to that in 2004?
Give a very brief answer. 0.44. What is the ratio of the Electricity production(% of total) in Jordan in 2001 to that in 2004?
Give a very brief answer. 1.06. What is the ratio of the Electricity production(% of total) in Tunisia in 2001 to that in 2004?
Offer a very short reply. 0.57. What is the ratio of the Electricity production(% of total) of Heavily indebted poor countries in 2001 to that in 2005?
Your answer should be compact. 0.51. What is the ratio of the Electricity production(% of total) of Germany in 2001 to that in 2005?
Your answer should be very brief. 0.37. What is the ratio of the Electricity production(% of total) in Jordan in 2001 to that in 2005?
Offer a terse response. 1.28. What is the ratio of the Electricity production(% of total) of Tunisia in 2001 to that in 2005?
Your response must be concise. 0.64. What is the ratio of the Electricity production(% of total) of Heavily indebted poor countries in 2002 to that in 2003?
Offer a terse response. 0.8. What is the ratio of the Electricity production(% of total) of Germany in 2002 to that in 2003?
Provide a short and direct response. 0.79. What is the ratio of the Electricity production(% of total) of Jordan in 2002 to that in 2003?
Ensure brevity in your answer.  0.87. What is the ratio of the Electricity production(% of total) of Tunisia in 2002 to that in 2003?
Your answer should be very brief. 0.87. What is the ratio of the Electricity production(% of total) of Heavily indebted poor countries in 2002 to that in 2004?
Give a very brief answer. 0.69. What is the ratio of the Electricity production(% of total) in Germany in 2002 to that in 2004?
Your answer should be very brief. 0.61. What is the ratio of the Electricity production(% of total) in Jordan in 2002 to that in 2004?
Your response must be concise. 0.98. What is the ratio of the Electricity production(% of total) in Tunisia in 2002 to that in 2004?
Give a very brief answer. 0.69. What is the ratio of the Electricity production(% of total) of Heavily indebted poor countries in 2002 to that in 2005?
Give a very brief answer. 0.58. What is the ratio of the Electricity production(% of total) in Germany in 2002 to that in 2005?
Your answer should be compact. 0.53. What is the ratio of the Electricity production(% of total) in Jordan in 2002 to that in 2005?
Provide a short and direct response. 1.19. What is the ratio of the Electricity production(% of total) in Tunisia in 2002 to that in 2005?
Your answer should be very brief. 0.76. What is the ratio of the Electricity production(% of total) in Heavily indebted poor countries in 2003 to that in 2004?
Provide a short and direct response. 0.86. What is the ratio of the Electricity production(% of total) in Germany in 2003 to that in 2004?
Offer a very short reply. 0.77. What is the ratio of the Electricity production(% of total) in Jordan in 2003 to that in 2004?
Your response must be concise. 1.12. What is the ratio of the Electricity production(% of total) of Tunisia in 2003 to that in 2004?
Ensure brevity in your answer.  0.79. What is the ratio of the Electricity production(% of total) of Heavily indebted poor countries in 2003 to that in 2005?
Your answer should be compact. 0.72. What is the ratio of the Electricity production(% of total) of Germany in 2003 to that in 2005?
Provide a succinct answer. 0.66. What is the ratio of the Electricity production(% of total) of Jordan in 2003 to that in 2005?
Your answer should be compact. 1.36. What is the ratio of the Electricity production(% of total) of Tunisia in 2003 to that in 2005?
Your answer should be compact. 0.88. What is the ratio of the Electricity production(% of total) of Heavily indebted poor countries in 2004 to that in 2005?
Your answer should be compact. 0.83. What is the ratio of the Electricity production(% of total) of Germany in 2004 to that in 2005?
Your answer should be very brief. 0.86. What is the ratio of the Electricity production(% of total) in Jordan in 2004 to that in 2005?
Provide a short and direct response. 1.21. What is the ratio of the Electricity production(% of total) of Tunisia in 2004 to that in 2005?
Offer a terse response. 1.11. What is the difference between the highest and the second highest Electricity production(% of total) of Heavily indebted poor countries?
Your answer should be compact. 0.16. What is the difference between the highest and the second highest Electricity production(% of total) in Germany?
Offer a terse response. 0.98. What is the difference between the highest and the second highest Electricity production(% of total) of Jordan?
Your answer should be very brief. 0.01. What is the difference between the highest and the second highest Electricity production(% of total) of Tunisia?
Offer a terse response. 0.04. What is the difference between the highest and the lowest Electricity production(% of total) in Heavily indebted poor countries?
Make the answer very short. 0.48. What is the difference between the highest and the lowest Electricity production(% of total) of Germany?
Offer a terse response. 4.56. What is the difference between the highest and the lowest Electricity production(% of total) of Jordan?
Your answer should be compact. 0.07. What is the difference between the highest and the lowest Electricity production(% of total) of Tunisia?
Give a very brief answer. 0.16. 